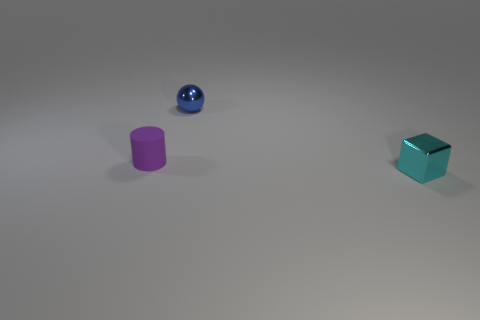Add 3 large cyan metal cubes. How many objects exist? 6 Subtract all cylinders. How many objects are left? 2 Subtract all small cyan spheres. Subtract all tiny spheres. How many objects are left? 2 Add 3 tiny spheres. How many tiny spheres are left? 4 Add 3 metallic cylinders. How many metallic cylinders exist? 3 Subtract 0 yellow balls. How many objects are left? 3 